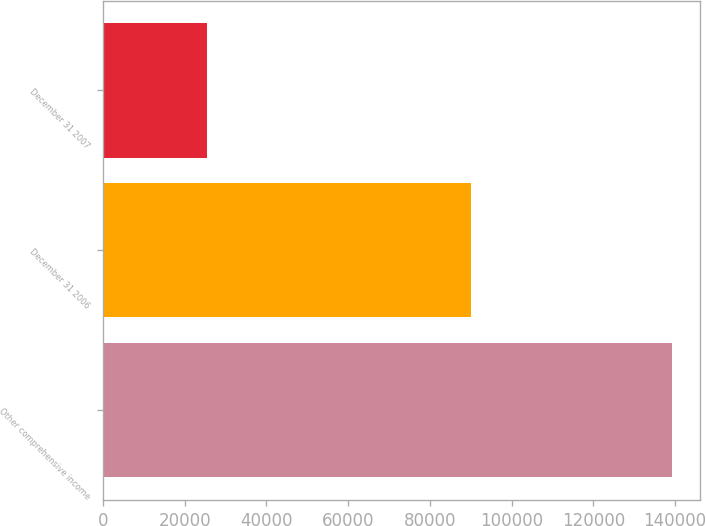Convert chart to OTSL. <chart><loc_0><loc_0><loc_500><loc_500><bar_chart><fcel>Other comprehensive income<fcel>December 31 2006<fcel>December 31 2007<nl><fcel>139165<fcel>89971<fcel>25328<nl></chart> 